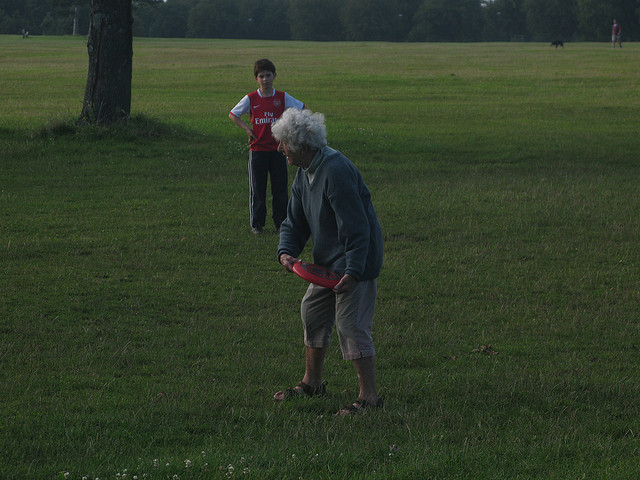<image>What animal is that? It's unclear what animal is in the image. It can be a dog or a human. What do their outfits have in common? It is not clear what their outfits have in common. It can be cotton, shoes, baggy, casual or nothing. What animal is that? It is ambiguous what animal is that. It can be seen as a dog or a human. What do their outfits have in common? I don't know if their outfits have something in common. It can be seen 'cotton' or 'nothing'. 